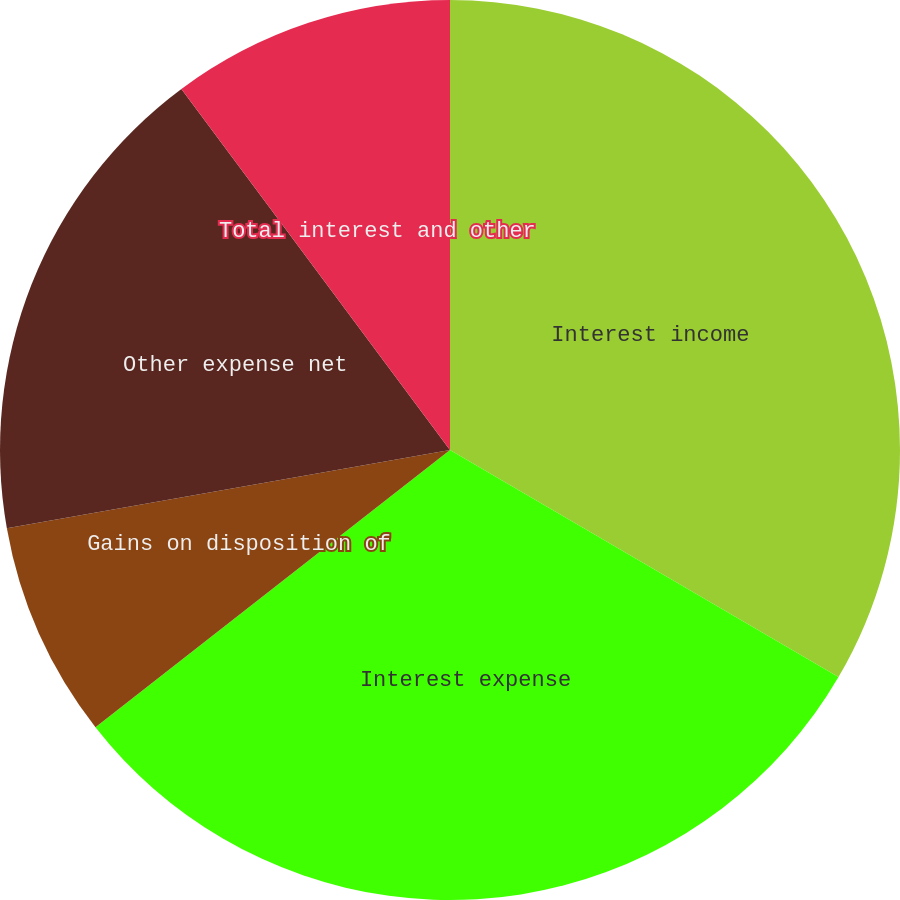Convert chart. <chart><loc_0><loc_0><loc_500><loc_500><pie_chart><fcel>Interest income<fcel>Interest expense<fcel>Gains on disposition of<fcel>Other expense net<fcel>Total interest and other<nl><fcel>33.42%<fcel>31.02%<fcel>7.78%<fcel>17.6%<fcel>10.18%<nl></chart> 